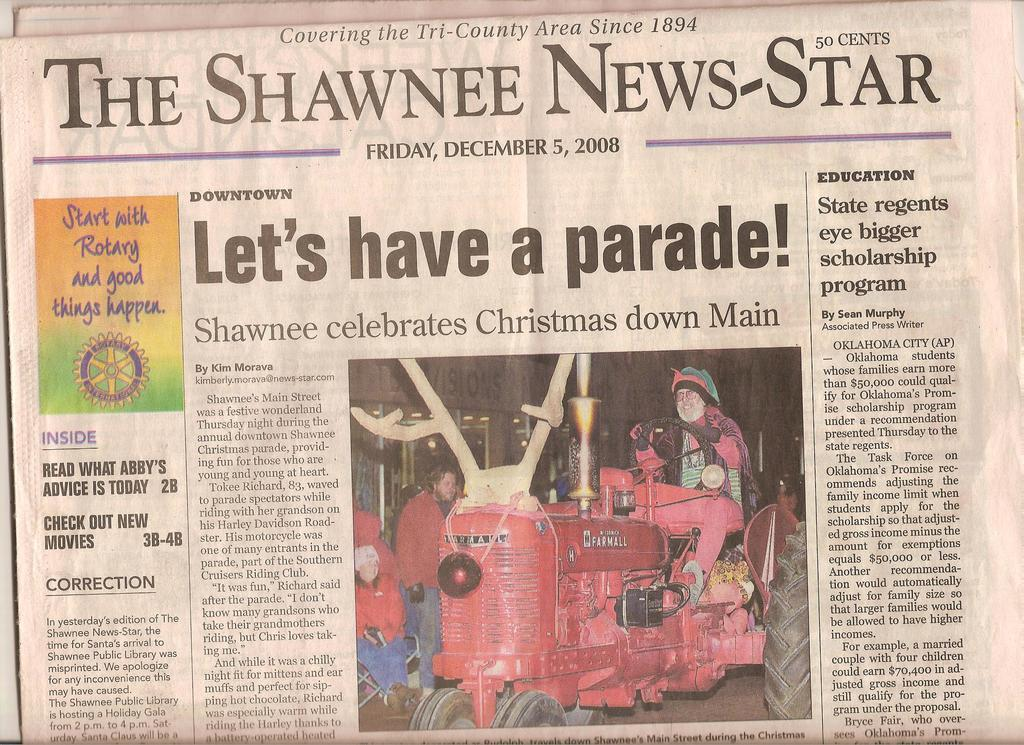Provide a one-sentence caption for the provided image. A copy of a Shawnee News-Star newspaper on the front page. 